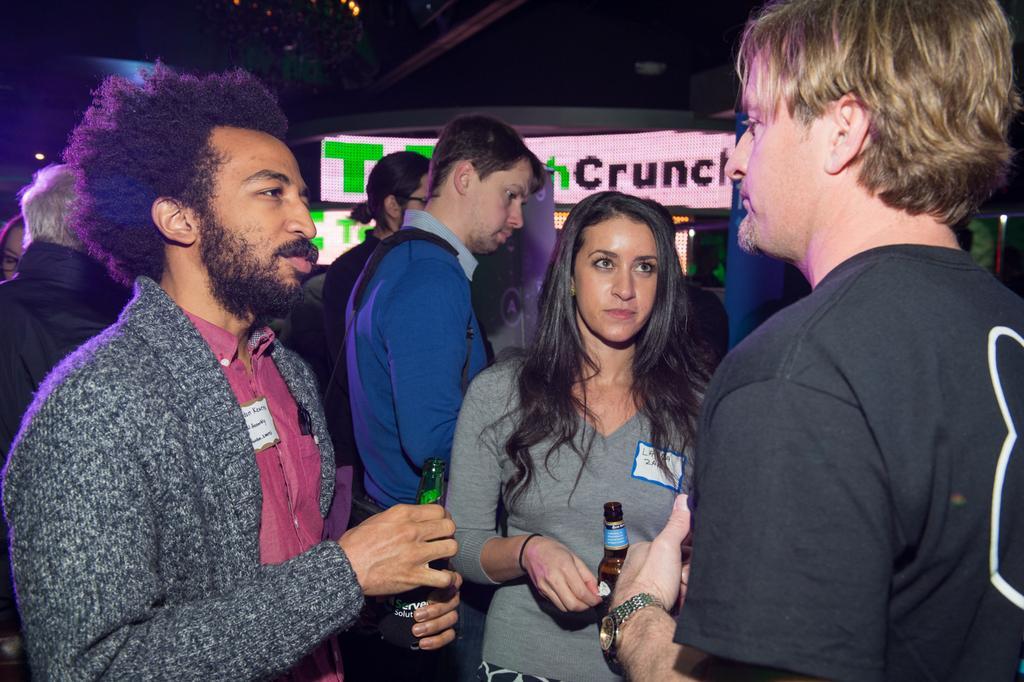Can you describe this image briefly? In this image I see 3 men and a woman and I see that these both are holding bottles in their hands and I see a watch on this hand. In the background it is a bit dark over here and I see few more people and I see the words written on this screen. 